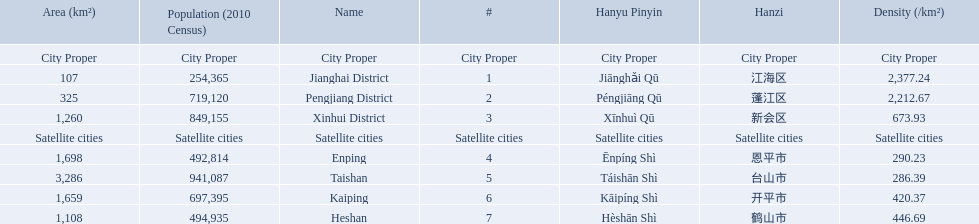What are all of the satellite cities? Enping, Taishan, Kaiping, Heshan. Of these, which has the highest population? Taishan. What cities are there in jiangmen? Jianghai District, Pengjiang District, Xinhui District, Enping, Taishan, Kaiping, Heshan. Of those, which ones are a city proper? Jianghai District, Pengjiang District, Xinhui District. Of those, which one has the smallest area in km2? Jianghai District. 